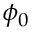Convert formula to latex. <formula><loc_0><loc_0><loc_500><loc_500>\phi _ { 0 }</formula> 